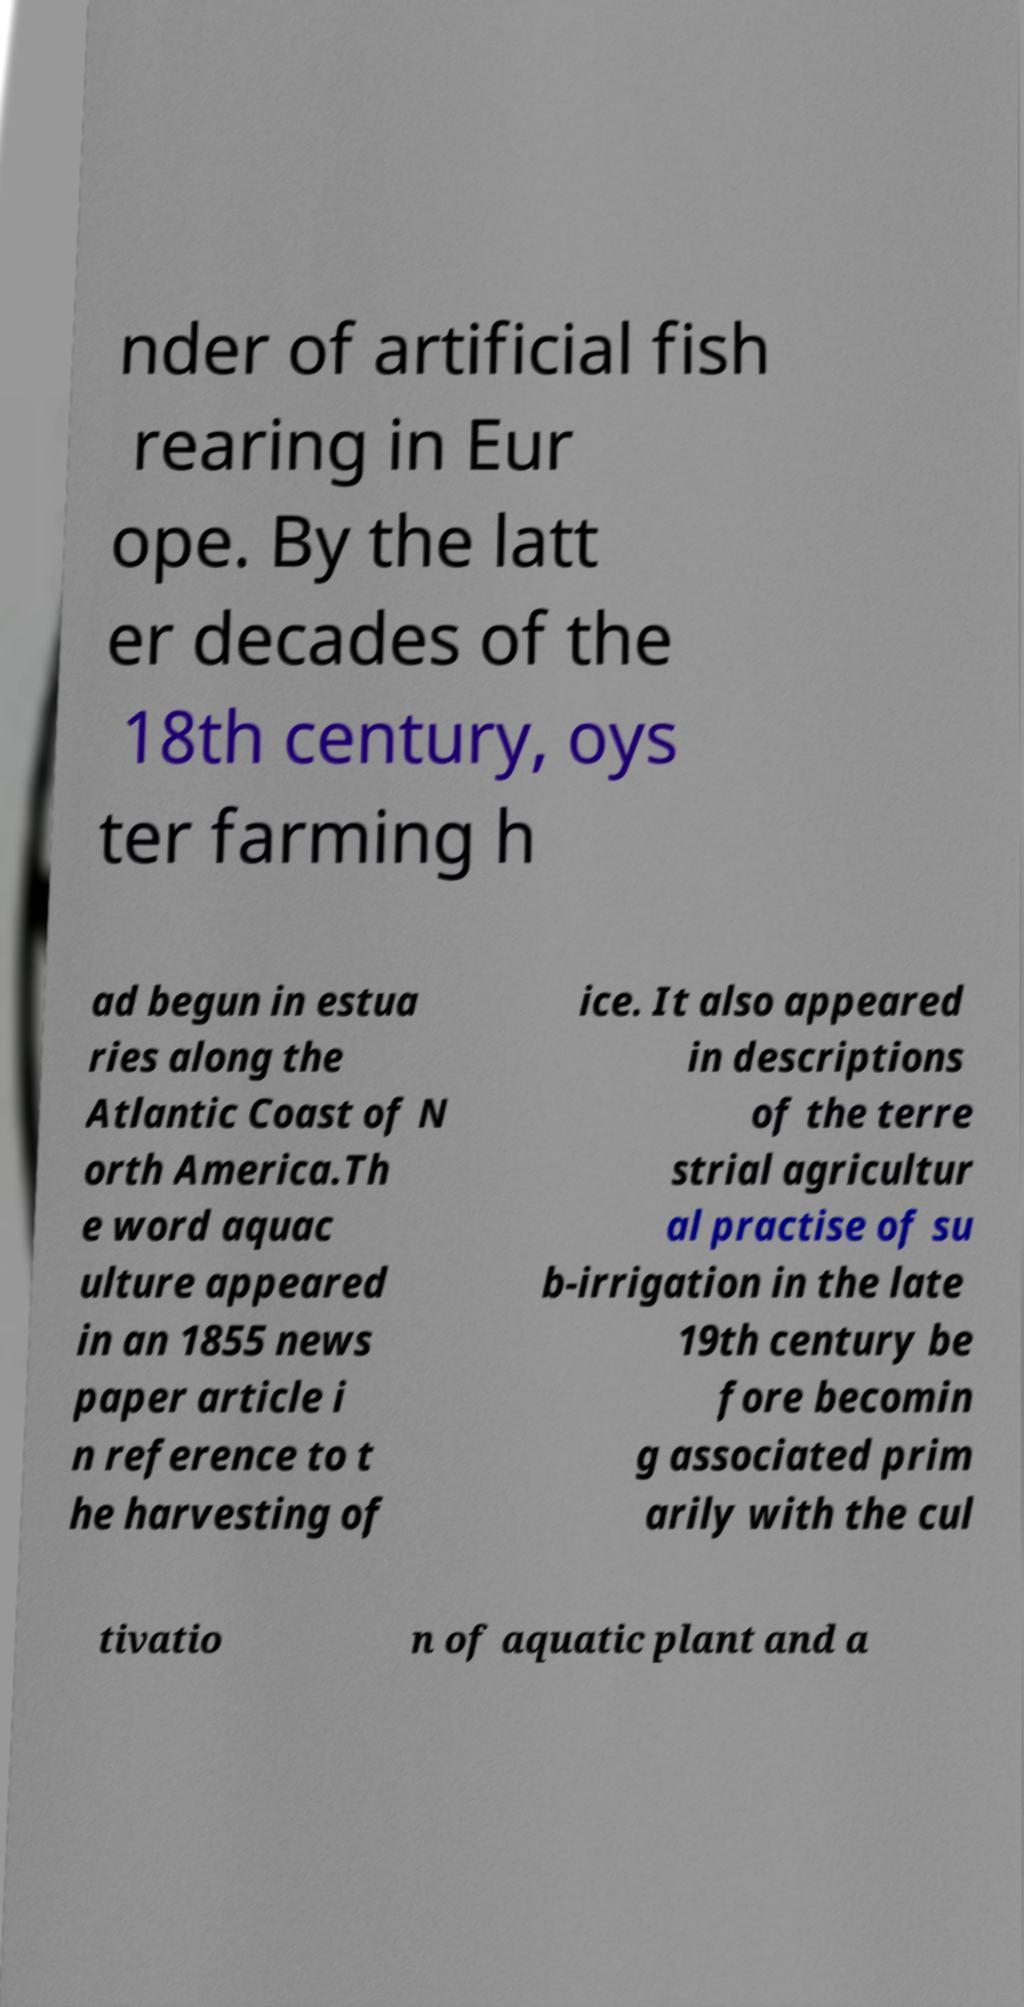Could you extract and type out the text from this image? nder of artificial fish rearing in Eur ope. By the latt er decades of the 18th century, oys ter farming h ad begun in estua ries along the Atlantic Coast of N orth America.Th e word aquac ulture appeared in an 1855 news paper article i n reference to t he harvesting of ice. It also appeared in descriptions of the terre strial agricultur al practise of su b-irrigation in the late 19th century be fore becomin g associated prim arily with the cul tivatio n of aquatic plant and a 